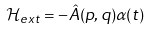<formula> <loc_0><loc_0><loc_500><loc_500>\mathcal { H } _ { e x t } = - \hat { A } ( p , q ) \alpha ( t )</formula> 